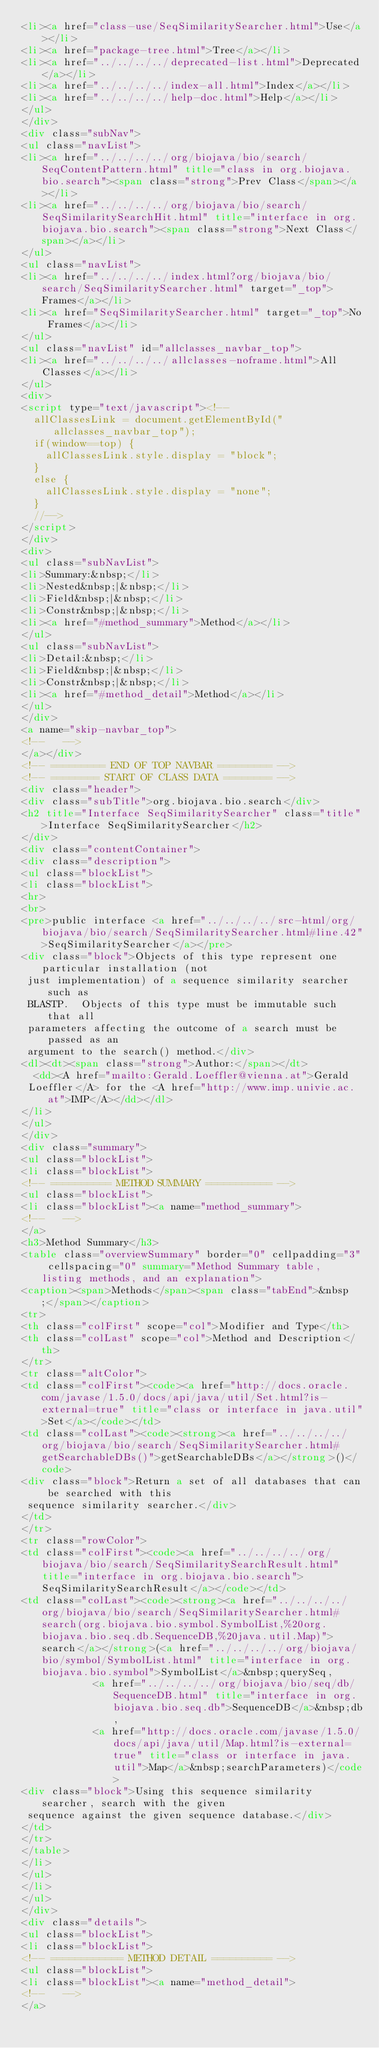Convert code to text. <code><loc_0><loc_0><loc_500><loc_500><_HTML_><li><a href="class-use/SeqSimilaritySearcher.html">Use</a></li>
<li><a href="package-tree.html">Tree</a></li>
<li><a href="../../../../deprecated-list.html">Deprecated</a></li>
<li><a href="../../../../index-all.html">Index</a></li>
<li><a href="../../../../help-doc.html">Help</a></li>
</ul>
</div>
<div class="subNav">
<ul class="navList">
<li><a href="../../../../org/biojava/bio/search/SeqContentPattern.html" title="class in org.biojava.bio.search"><span class="strong">Prev Class</span></a></li>
<li><a href="../../../../org/biojava/bio/search/SeqSimilaritySearchHit.html" title="interface in org.biojava.bio.search"><span class="strong">Next Class</span></a></li>
</ul>
<ul class="navList">
<li><a href="../../../../index.html?org/biojava/bio/search/SeqSimilaritySearcher.html" target="_top">Frames</a></li>
<li><a href="SeqSimilaritySearcher.html" target="_top">No Frames</a></li>
</ul>
<ul class="navList" id="allclasses_navbar_top">
<li><a href="../../../../allclasses-noframe.html">All Classes</a></li>
</ul>
<div>
<script type="text/javascript"><!--
  allClassesLink = document.getElementById("allclasses_navbar_top");
  if(window==top) {
    allClassesLink.style.display = "block";
  }
  else {
    allClassesLink.style.display = "none";
  }
  //-->
</script>
</div>
<div>
<ul class="subNavList">
<li>Summary:&nbsp;</li>
<li>Nested&nbsp;|&nbsp;</li>
<li>Field&nbsp;|&nbsp;</li>
<li>Constr&nbsp;|&nbsp;</li>
<li><a href="#method_summary">Method</a></li>
</ul>
<ul class="subNavList">
<li>Detail:&nbsp;</li>
<li>Field&nbsp;|&nbsp;</li>
<li>Constr&nbsp;|&nbsp;</li>
<li><a href="#method_detail">Method</a></li>
</ul>
</div>
<a name="skip-navbar_top">
<!--   -->
</a></div>
<!-- ========= END OF TOP NAVBAR ========= -->
<!-- ======== START OF CLASS DATA ======== -->
<div class="header">
<div class="subTitle">org.biojava.bio.search</div>
<h2 title="Interface SeqSimilaritySearcher" class="title">Interface SeqSimilaritySearcher</h2>
</div>
<div class="contentContainer">
<div class="description">
<ul class="blockList">
<li class="blockList">
<hr>
<br>
<pre>public interface <a href="../../../../src-html/org/biojava/bio/search/SeqSimilaritySearcher.html#line.42">SeqSimilaritySearcher</a></pre>
<div class="block">Objects of this type represent one particular installation (not
 just implementation) of a sequence similarity searcher such as
 BLASTP.  Objects of this type must be immutable such that all
 parameters affecting the outcome of a search must be passed as an
 argument to the search() method.</div>
<dl><dt><span class="strong">Author:</span></dt>
  <dd><A href="mailto:Gerald.Loeffler@vienna.at">Gerald
 Loeffler</A> for the <A href="http://www.imp.univie.ac.at">IMP</A></dd></dl>
</li>
</ul>
</div>
<div class="summary">
<ul class="blockList">
<li class="blockList">
<!-- ========== METHOD SUMMARY =========== -->
<ul class="blockList">
<li class="blockList"><a name="method_summary">
<!--   -->
</a>
<h3>Method Summary</h3>
<table class="overviewSummary" border="0" cellpadding="3" cellspacing="0" summary="Method Summary table, listing methods, and an explanation">
<caption><span>Methods</span><span class="tabEnd">&nbsp;</span></caption>
<tr>
<th class="colFirst" scope="col">Modifier and Type</th>
<th class="colLast" scope="col">Method and Description</th>
</tr>
<tr class="altColor">
<td class="colFirst"><code><a href="http://docs.oracle.com/javase/1.5.0/docs/api/java/util/Set.html?is-external=true" title="class or interface in java.util">Set</a></code></td>
<td class="colLast"><code><strong><a href="../../../../org/biojava/bio/search/SeqSimilaritySearcher.html#getSearchableDBs()">getSearchableDBs</a></strong>()</code>
<div class="block">Return a set of all databases that can be searched with this
 sequence similarity searcher.</div>
</td>
</tr>
<tr class="rowColor">
<td class="colFirst"><code><a href="../../../../org/biojava/bio/search/SeqSimilaritySearchResult.html" title="interface in org.biojava.bio.search">SeqSimilaritySearchResult</a></code></td>
<td class="colLast"><code><strong><a href="../../../../org/biojava/bio/search/SeqSimilaritySearcher.html#search(org.biojava.bio.symbol.SymbolList,%20org.biojava.bio.seq.db.SequenceDB,%20java.util.Map)">search</a></strong>(<a href="../../../../org/biojava/bio/symbol/SymbolList.html" title="interface in org.biojava.bio.symbol">SymbolList</a>&nbsp;querySeq,
            <a href="../../../../org/biojava/bio/seq/db/SequenceDB.html" title="interface in org.biojava.bio.seq.db">SequenceDB</a>&nbsp;db,
            <a href="http://docs.oracle.com/javase/1.5.0/docs/api/java/util/Map.html?is-external=true" title="class or interface in java.util">Map</a>&nbsp;searchParameters)</code>
<div class="block">Using this sequence similarity searcher, search with the given
 sequence against the given sequence database.</div>
</td>
</tr>
</table>
</li>
</ul>
</li>
</ul>
</div>
<div class="details">
<ul class="blockList">
<li class="blockList">
<!-- ============ METHOD DETAIL ========== -->
<ul class="blockList">
<li class="blockList"><a name="method_detail">
<!--   -->
</a></code> 